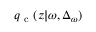Convert formula to latex. <formula><loc_0><loc_0><loc_500><loc_500>{ q _ { c } } ( z | \omega , \Delta _ { \omega } )</formula> 